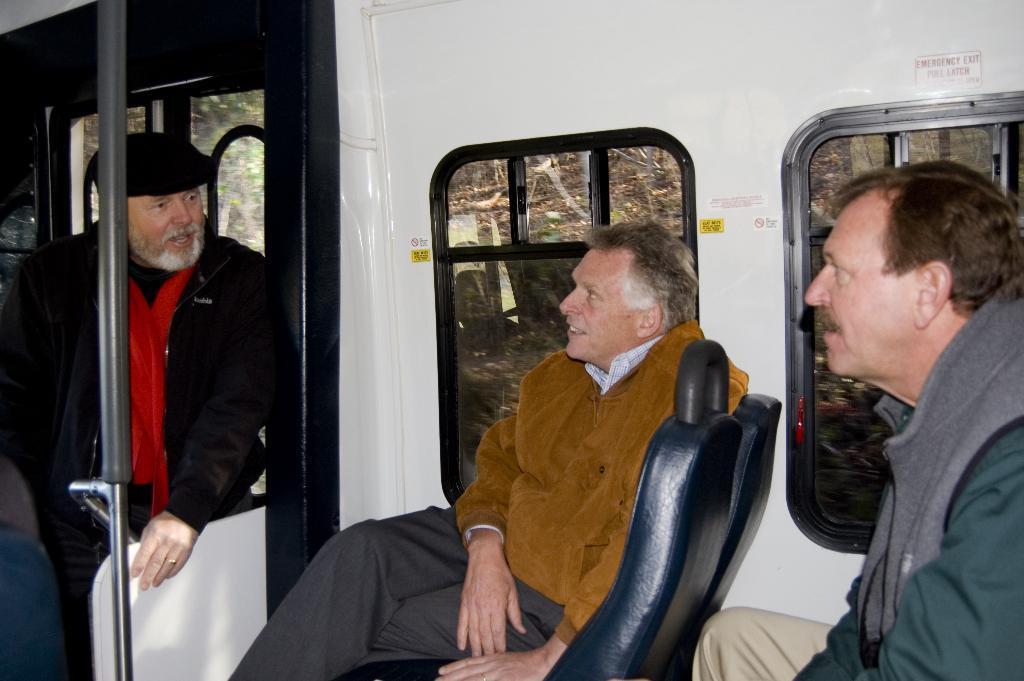Could you give a brief overview of what you see in this image? This image is clicked inside a train, there are two persons sitting beside a window on left side and a man standing in front of window. 